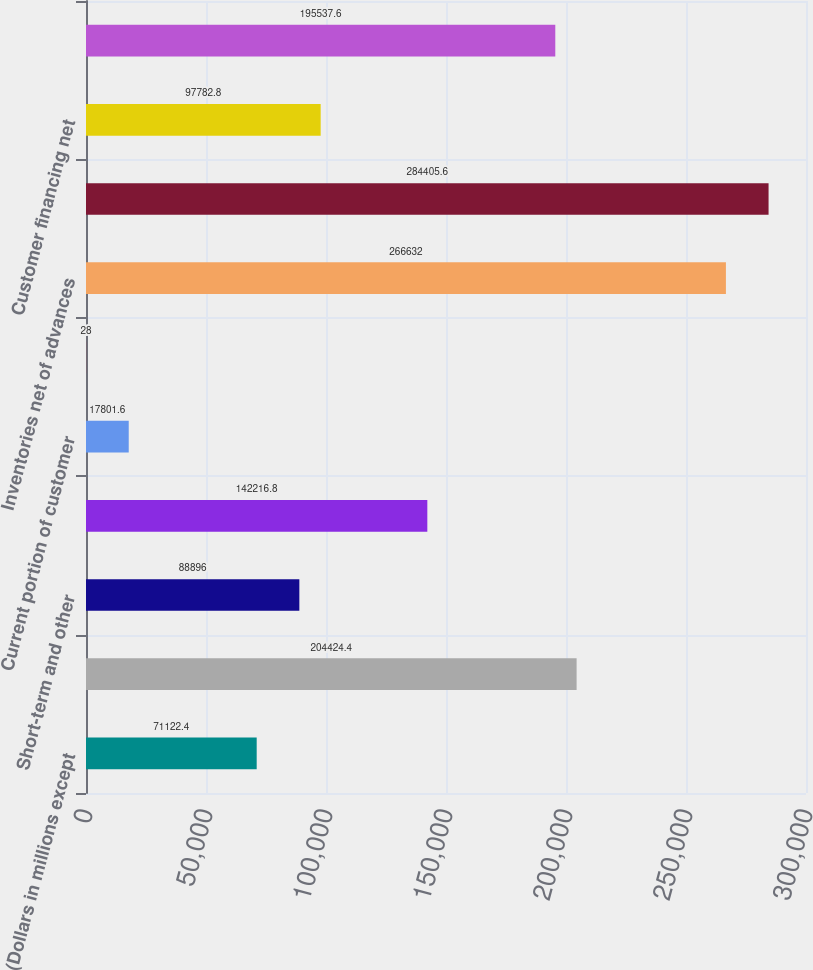Convert chart to OTSL. <chart><loc_0><loc_0><loc_500><loc_500><bar_chart><fcel>(Dollars in millions except<fcel>Cash and cash equivalents<fcel>Short-term and other<fcel>Accounts receivable net<fcel>Current portion of customer<fcel>Deferred income taxes<fcel>Inventories net of advances<fcel>Total current assets<fcel>Customer financing net<fcel>Property plant and equipment<nl><fcel>71122.4<fcel>204424<fcel>88896<fcel>142217<fcel>17801.6<fcel>28<fcel>266632<fcel>284406<fcel>97782.8<fcel>195538<nl></chart> 